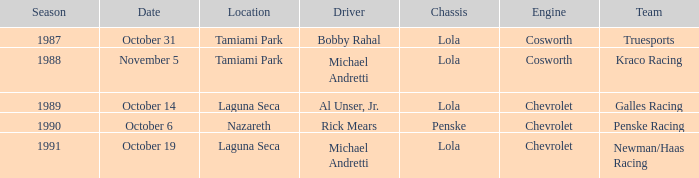On what date was the race at Nazareth? October 6. Could you parse the entire table? {'header': ['Season', 'Date', 'Location', 'Driver', 'Chassis', 'Engine', 'Team'], 'rows': [['1987', 'October 31', 'Tamiami Park', 'Bobby Rahal', 'Lola', 'Cosworth', 'Truesports'], ['1988', 'November 5', 'Tamiami Park', 'Michael Andretti', 'Lola', 'Cosworth', 'Kraco Racing'], ['1989', 'October 14', 'Laguna Seca', 'Al Unser, Jr.', 'Lola', 'Chevrolet', 'Galles Racing'], ['1990', 'October 6', 'Nazareth', 'Rick Mears', 'Penske', 'Chevrolet', 'Penske Racing'], ['1991', 'October 19', 'Laguna Seca', 'Michael Andretti', 'Lola', 'Chevrolet', 'Newman/Haas Racing']]} 